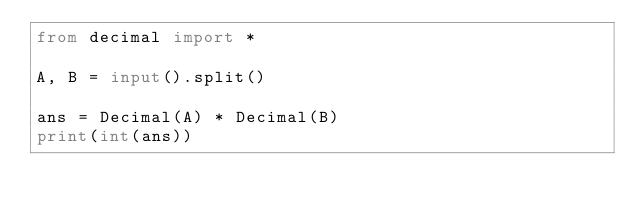<code> <loc_0><loc_0><loc_500><loc_500><_Python_>from decimal import *

A, B = input().split()

ans = Decimal(A) * Decimal(B)
print(int(ans))</code> 